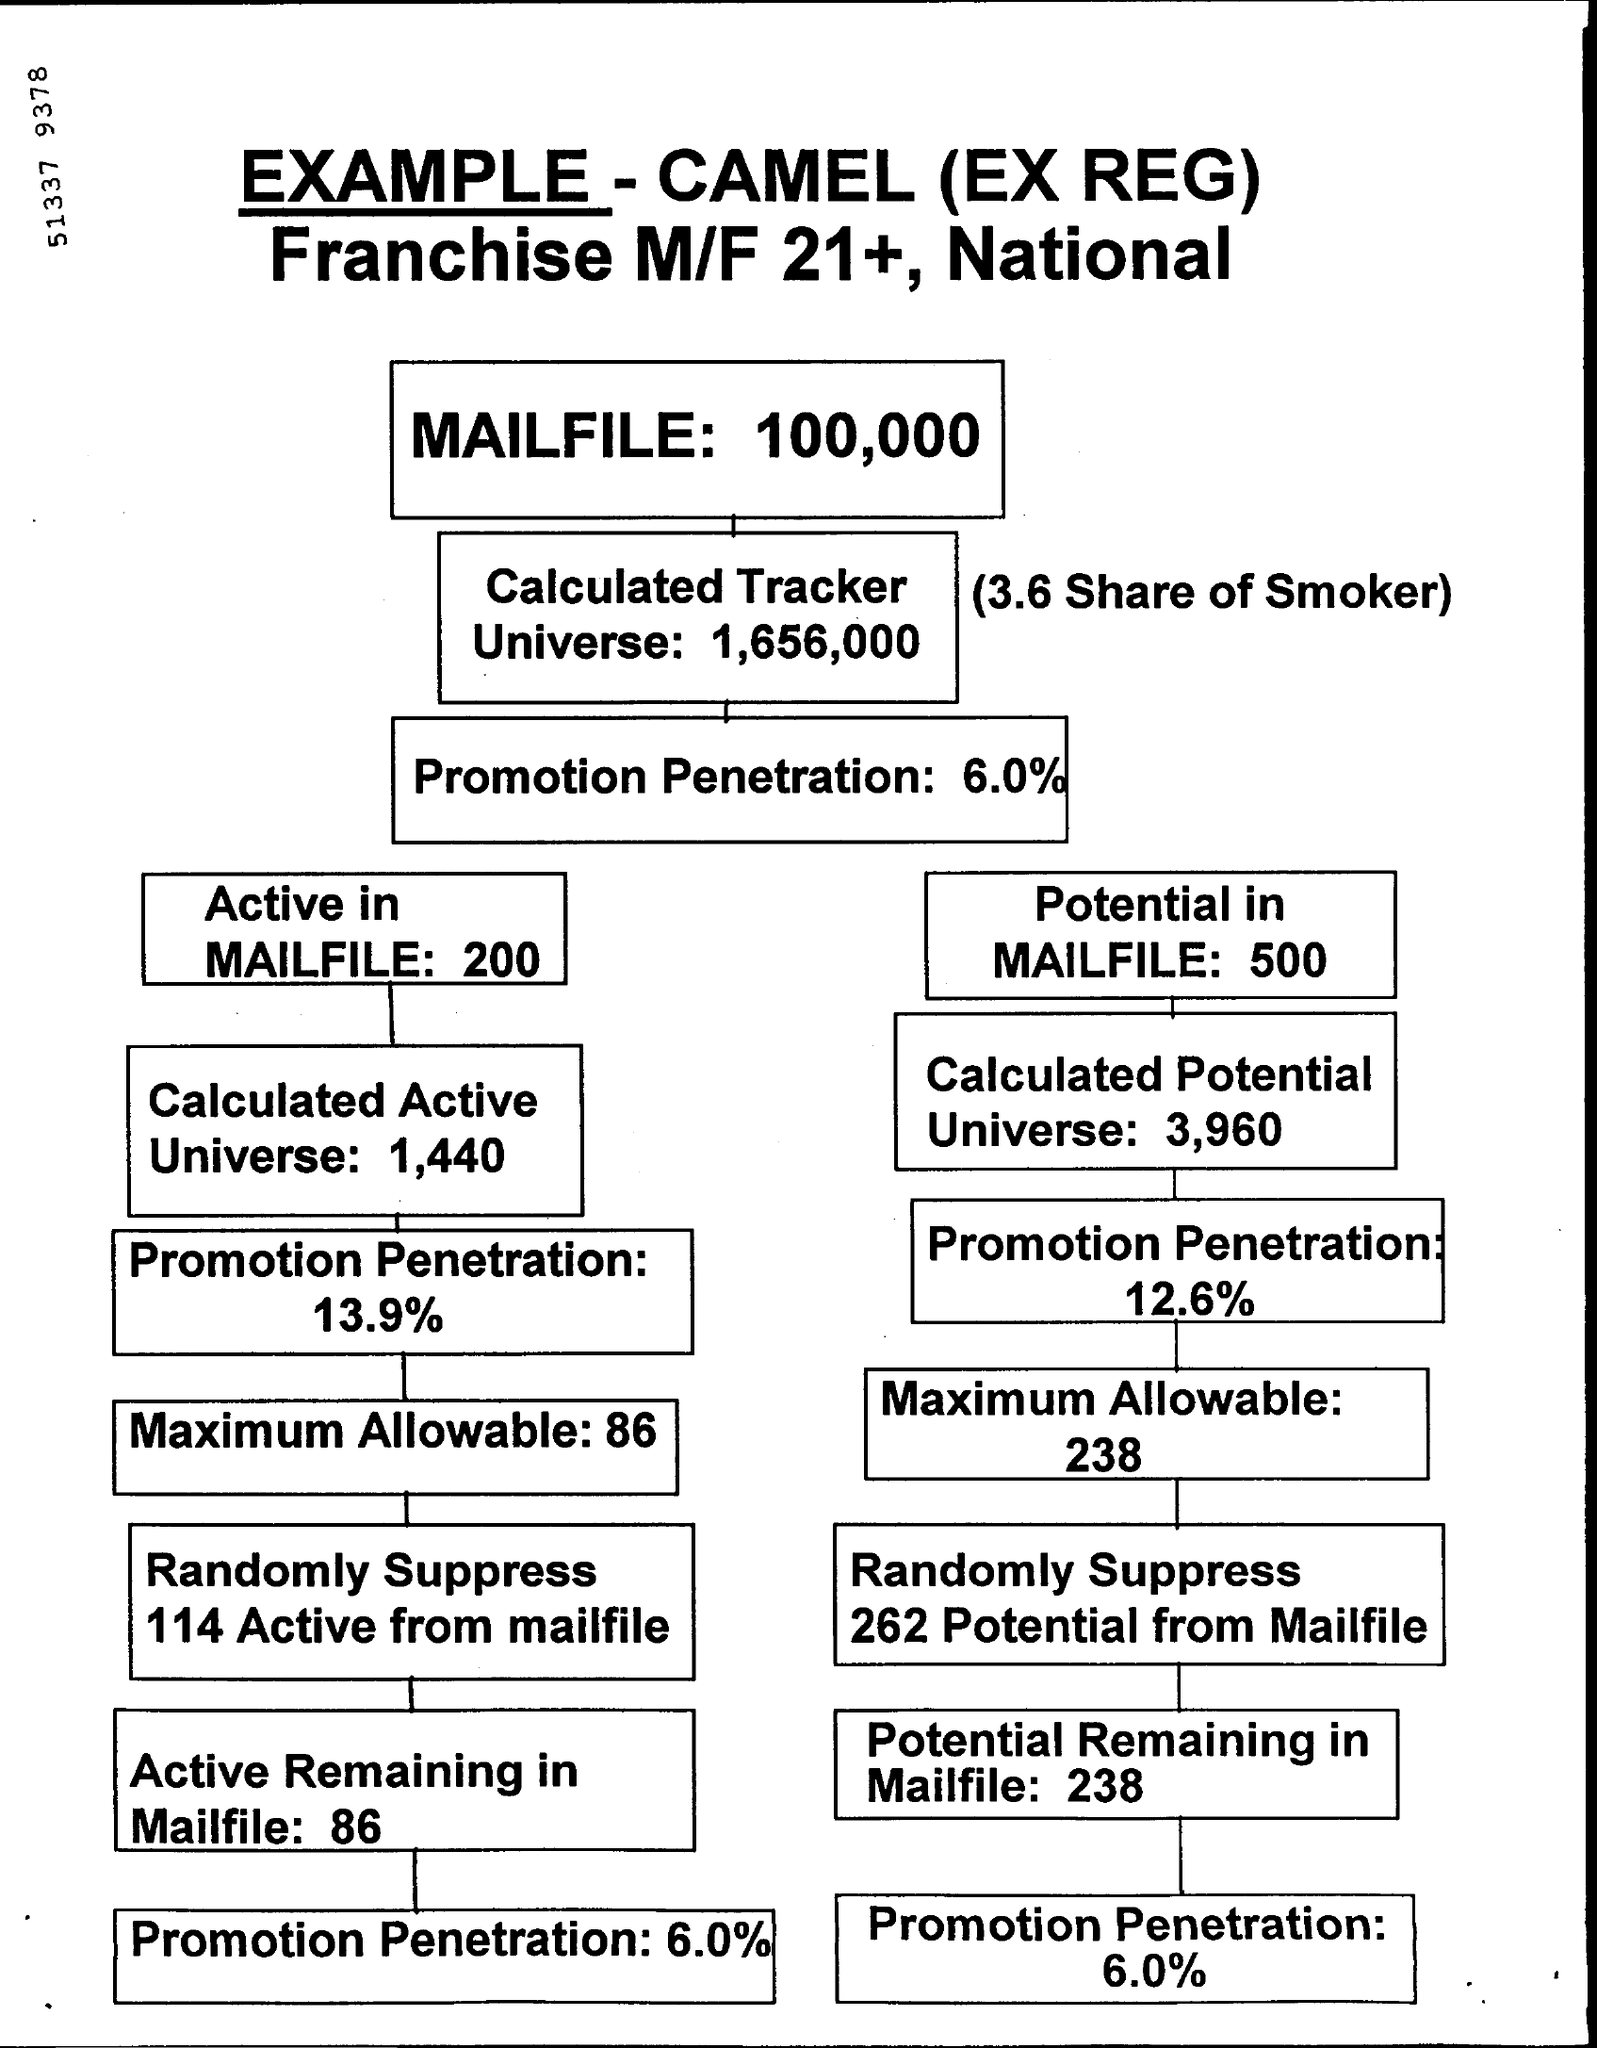List a handful of essential elements in this visual. The maximum allowable number in the active mailfile is 86. The potential remaining in the mail file is 238. 